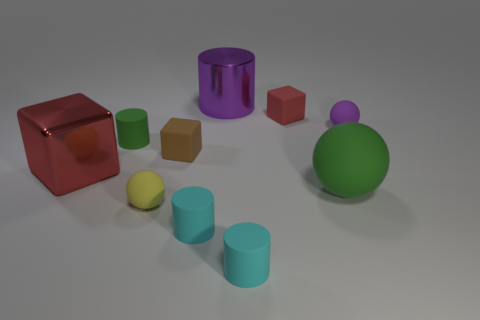Does the green thing on the left side of the red rubber thing have the same size as the large purple cylinder?
Your answer should be compact. No. Is the number of shiny things less than the number of large red metal cubes?
Your answer should be very brief. No. There is a large metallic thing that is in front of the large purple shiny object that is left of the red cube right of the small brown rubber thing; what is its shape?
Your answer should be compact. Cube. Is there a small cyan thing made of the same material as the yellow thing?
Provide a short and direct response. Yes. Does the tiny matte cylinder on the left side of the small yellow sphere have the same color as the big thing behind the small brown block?
Provide a succinct answer. No. Are there fewer big red cubes behind the small green matte thing than large red things?
Keep it short and to the point. Yes. How many things are red metallic cubes or green things in front of the big red metal object?
Keep it short and to the point. 2. There is a big ball that is made of the same material as the tiny green cylinder; what color is it?
Make the answer very short. Green. How many objects are either brown things or purple shiny cylinders?
Your answer should be compact. 2. The other metal object that is the same size as the red shiny object is what color?
Provide a short and direct response. Purple. 